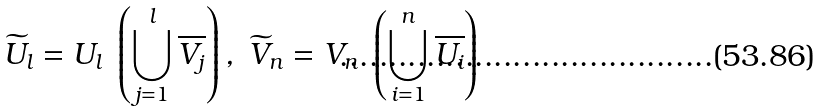<formula> <loc_0><loc_0><loc_500><loc_500>\widetilde { U } _ { l } = U _ { l } \ \left ( \bigcup _ { j = 1 } ^ { l } \overline { V _ { j } } \right ) , \ \widetilde { V } _ { n } = V _ { n } \ \left ( \bigcup _ { i = 1 } ^ { n } \overline { U _ { i } } \right )</formula> 